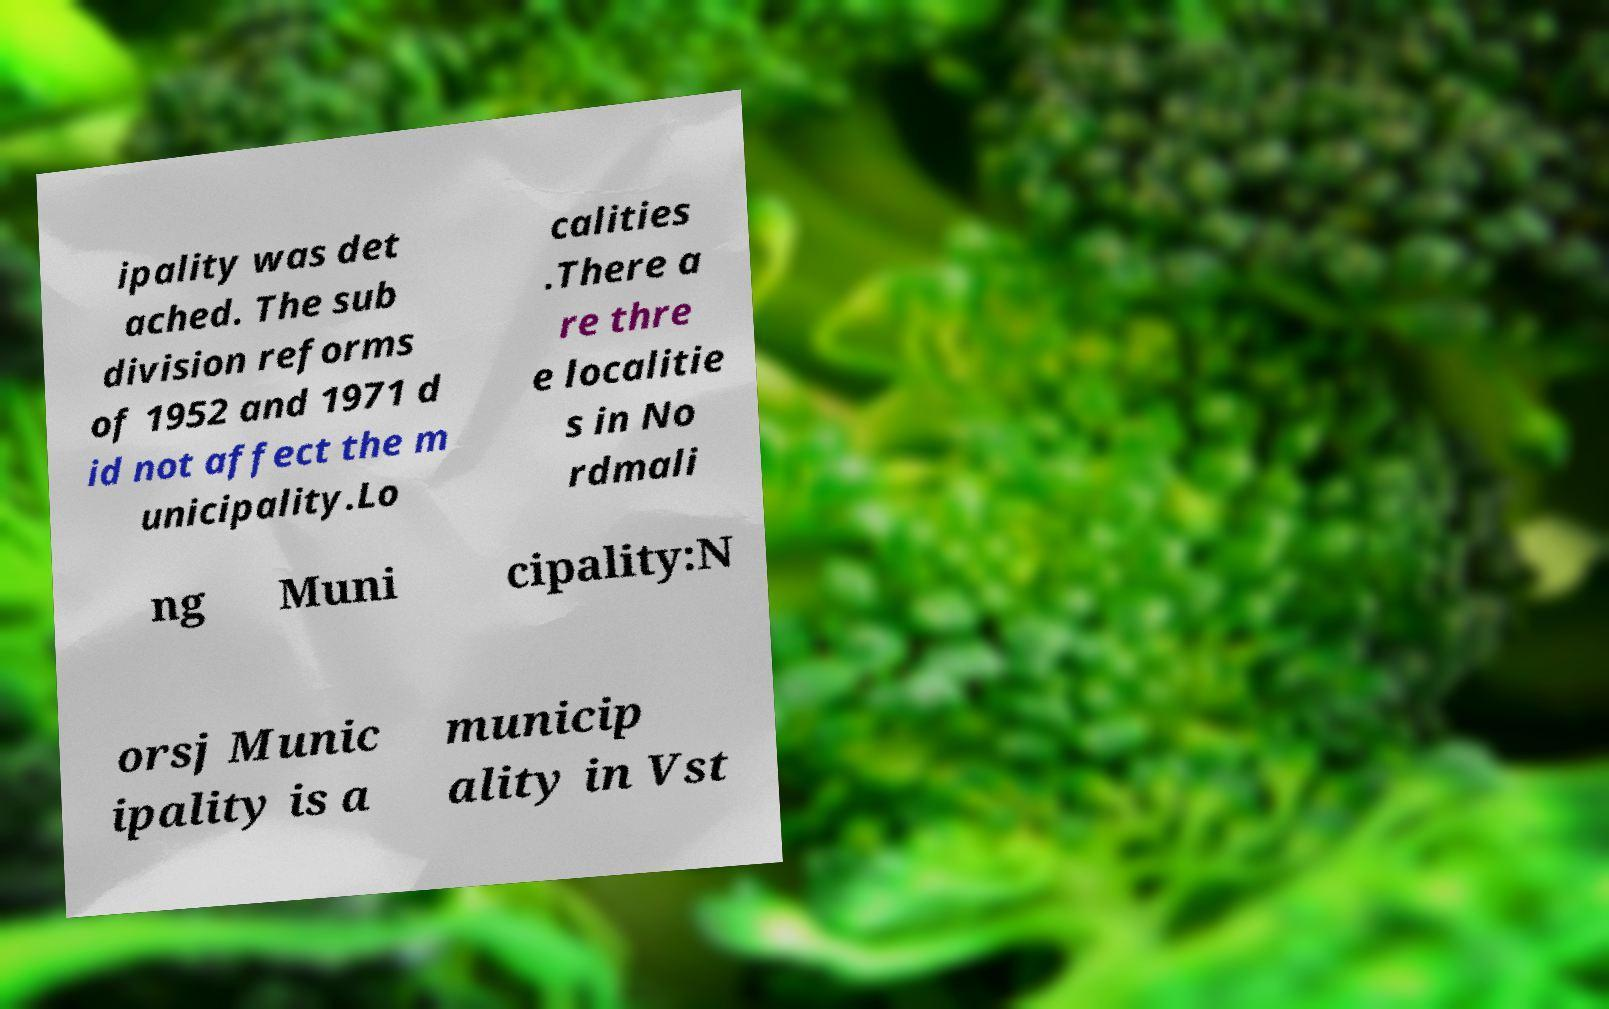Could you extract and type out the text from this image? ipality was det ached. The sub division reforms of 1952 and 1971 d id not affect the m unicipality.Lo calities .There a re thre e localitie s in No rdmali ng Muni cipality:N orsj Munic ipality is a municip ality in Vst 